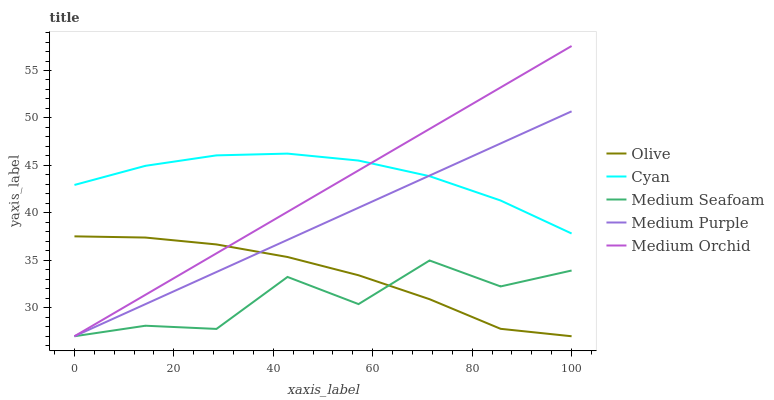Does Medium Seafoam have the minimum area under the curve?
Answer yes or no. Yes. Does Cyan have the maximum area under the curve?
Answer yes or no. Yes. Does Medium Purple have the minimum area under the curve?
Answer yes or no. No. Does Medium Purple have the maximum area under the curve?
Answer yes or no. No. Is Medium Orchid the smoothest?
Answer yes or no. Yes. Is Medium Seafoam the roughest?
Answer yes or no. Yes. Is Cyan the smoothest?
Answer yes or no. No. Is Cyan the roughest?
Answer yes or no. No. Does Olive have the lowest value?
Answer yes or no. Yes. Does Cyan have the lowest value?
Answer yes or no. No. Does Medium Orchid have the highest value?
Answer yes or no. Yes. Does Cyan have the highest value?
Answer yes or no. No. Is Medium Seafoam less than Cyan?
Answer yes or no. Yes. Is Cyan greater than Medium Seafoam?
Answer yes or no. Yes. Does Medium Seafoam intersect Olive?
Answer yes or no. Yes. Is Medium Seafoam less than Olive?
Answer yes or no. No. Is Medium Seafoam greater than Olive?
Answer yes or no. No. Does Medium Seafoam intersect Cyan?
Answer yes or no. No. 